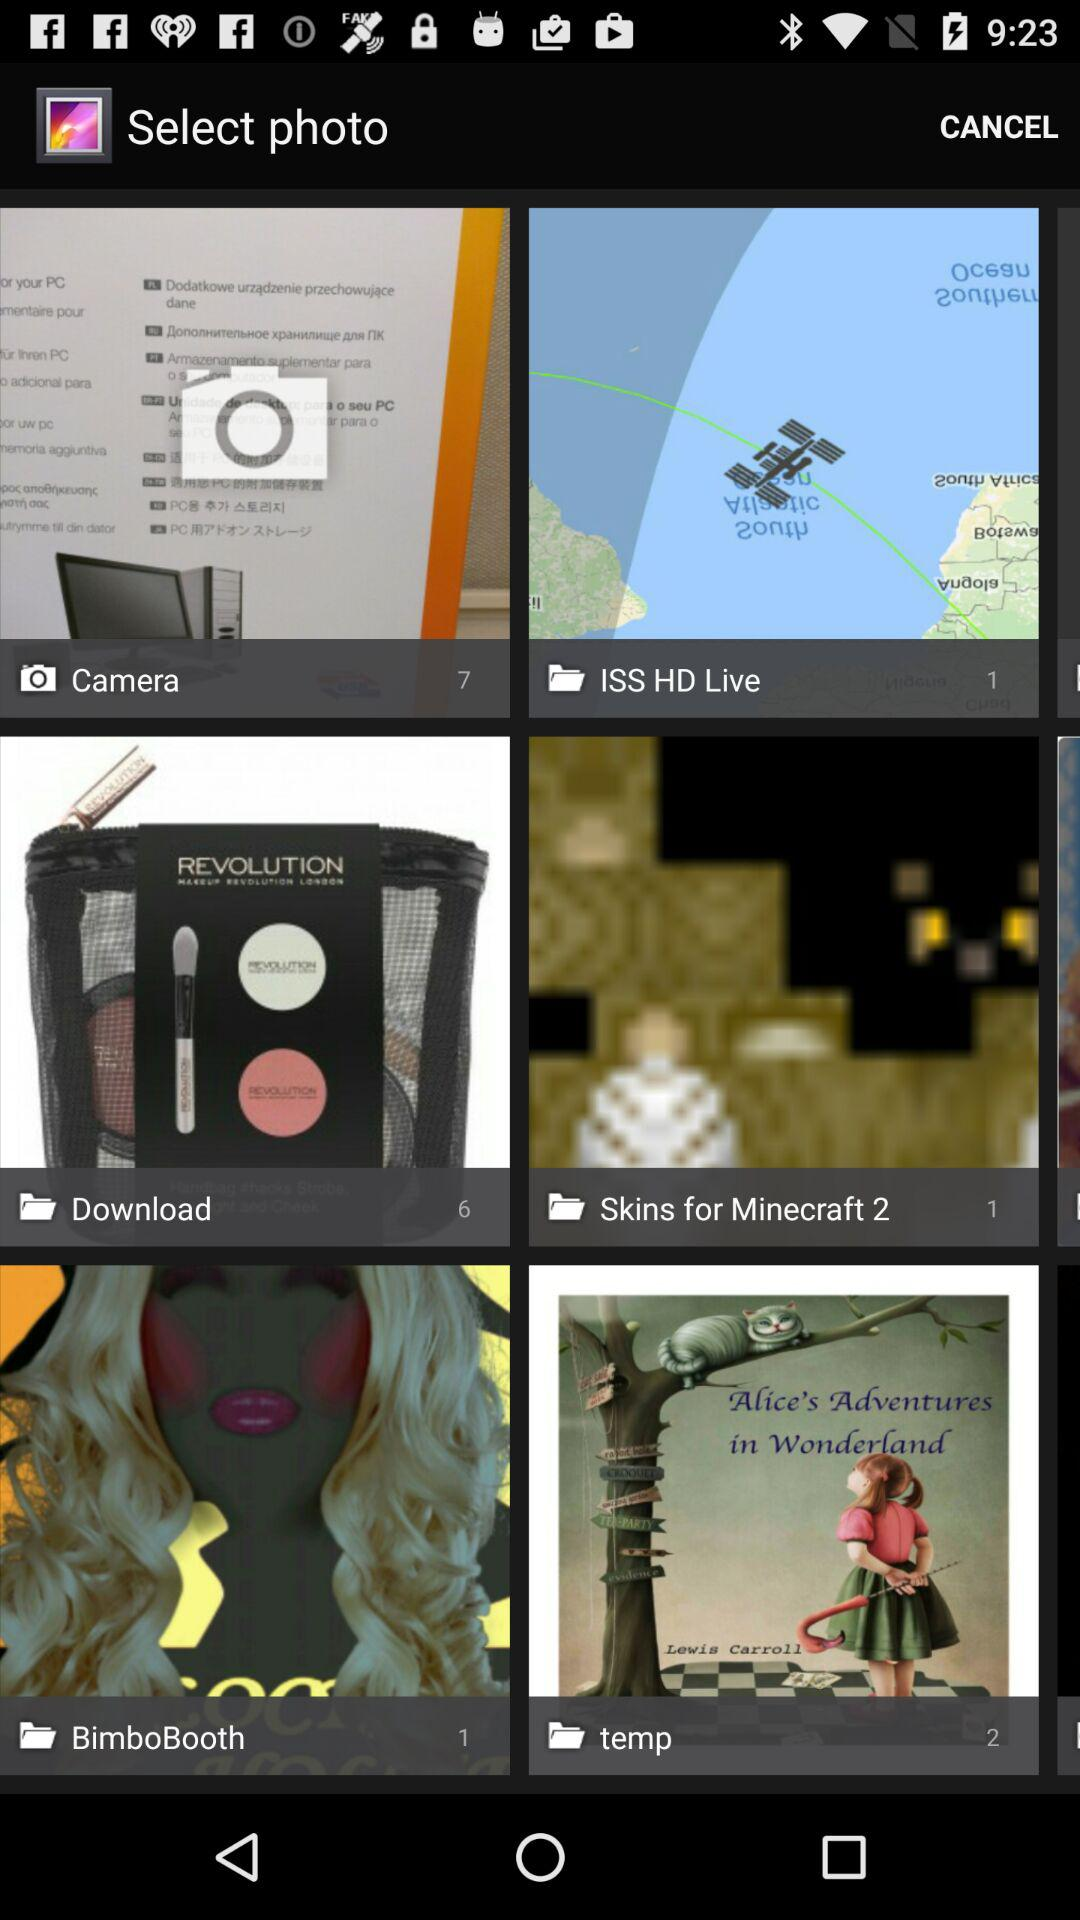How many photos are in the camera folder? There are 7 photos in the camera folder. 